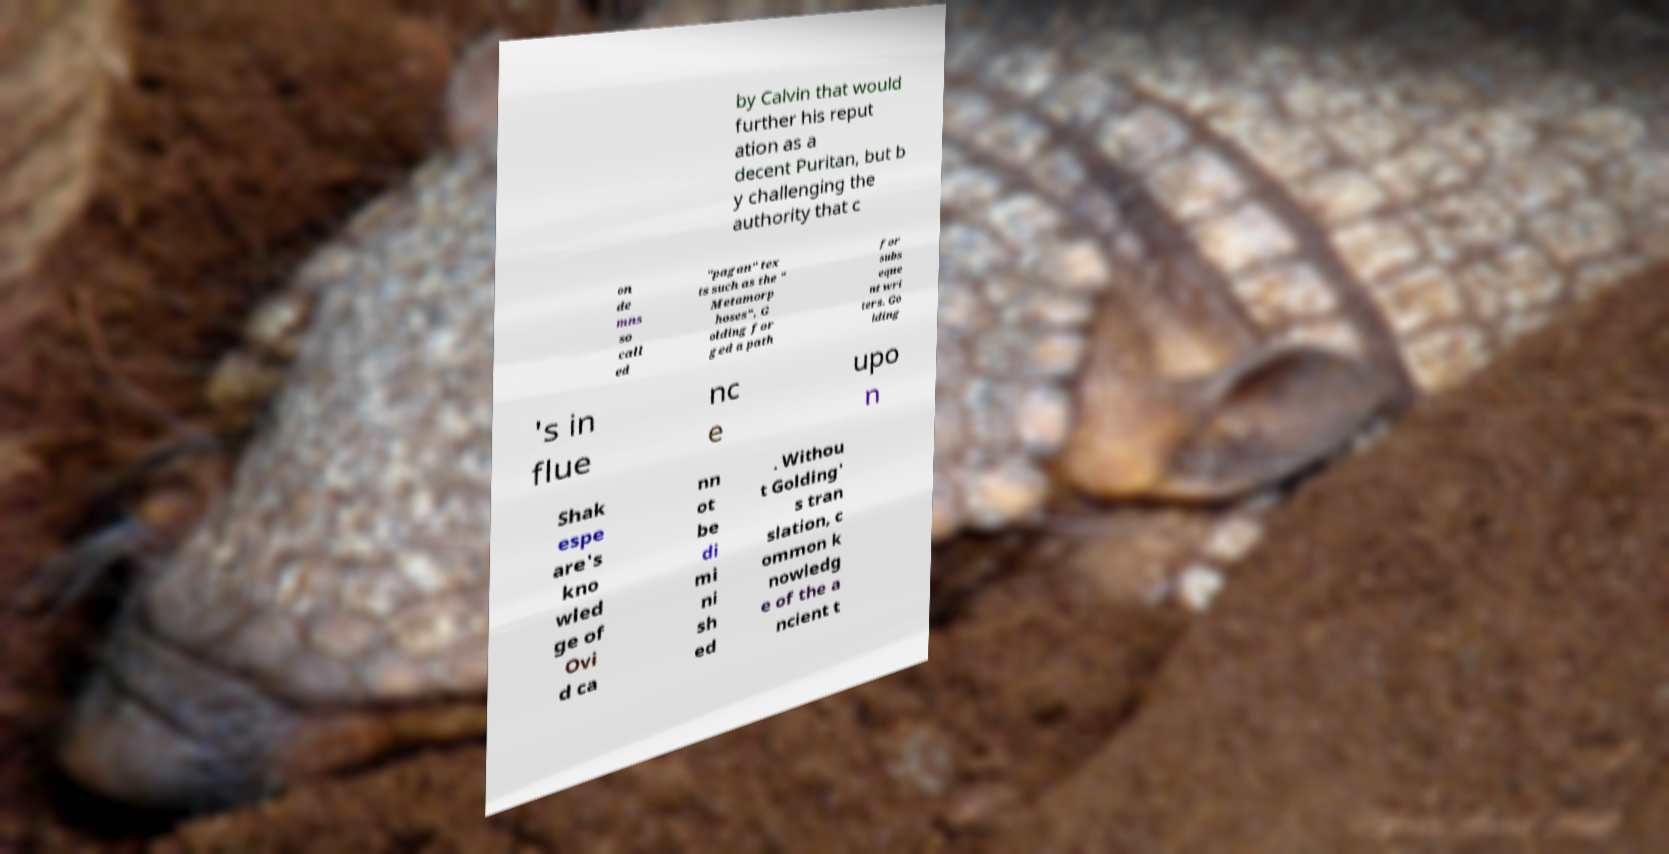For documentation purposes, I need the text within this image transcribed. Could you provide that? by Calvin that would further his reput ation as a decent Puritan, but b y challenging the authority that c on de mns so call ed "pagan" tex ts such as the " Metamorp hoses", G olding for ged a path for subs eque nt wri ters. Go lding 's in flue nc e upo n Shak espe are's kno wled ge of Ovi d ca nn ot be di mi ni sh ed . Withou t Golding' s tran slation, c ommon k nowledg e of the a ncient t 